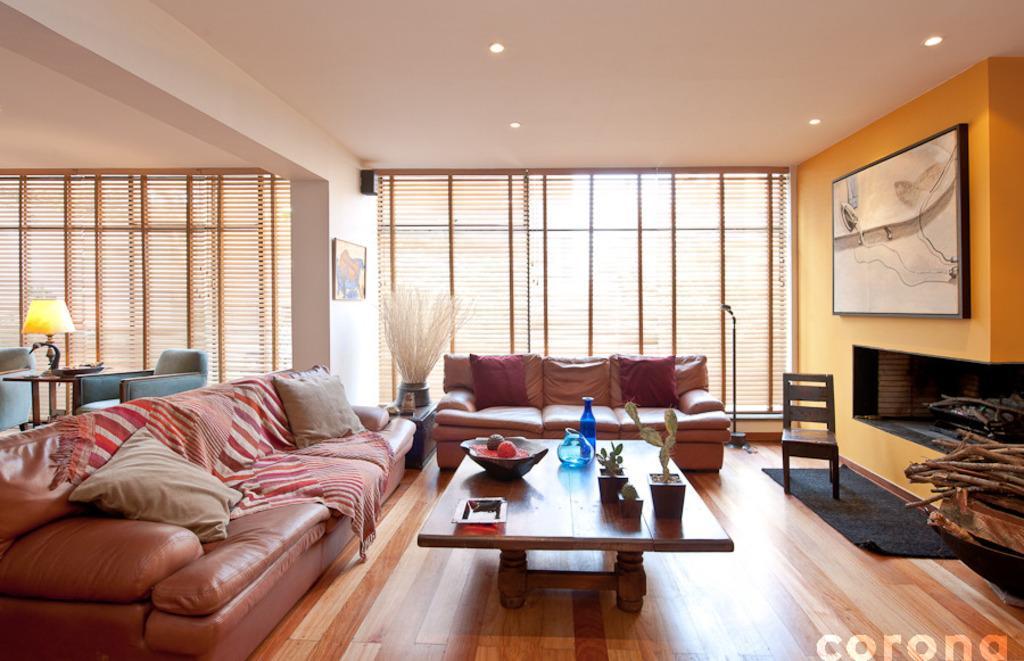Could you give a brief overview of what you see in this image? In this picture there is a sofa set and pillows on the set. There is a table on which bowls, bottles were placed. A photo frame attached to the wall. In the background there are curtains and a lamp placed on the table. There is a chair. A photo frame is attached to the wall. In the background there are curtains and a lamp placed on the table. 